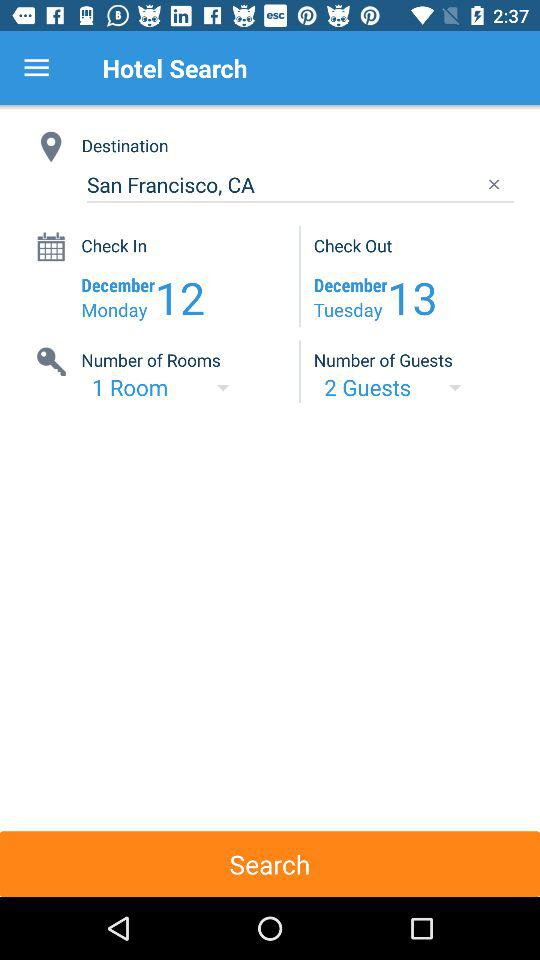What is the number of guests? The number of guests is 2. 